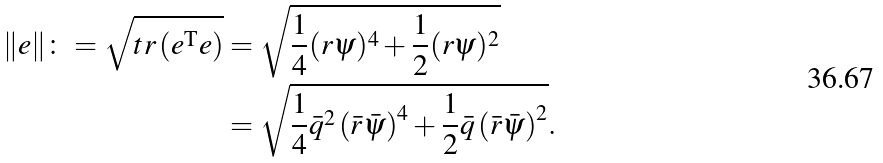<formula> <loc_0><loc_0><loc_500><loc_500>\| e \| \colon = \sqrt { t r \left ( e ^ { \text {T} } e \right ) } & = \sqrt { \frac { 1 } { 4 } ( r \psi ) ^ { 4 } + \frac { 1 } { 2 } ( r \psi ) ^ { 2 } } \\ & = \sqrt { \frac { 1 } { 4 } \bar { q } ^ { 2 } \left ( \bar { r } \bar { \psi } \right ) ^ { 4 } + \frac { 1 } { 2 } \bar { q } \left ( \bar { r } \bar { \psi } \right ) ^ { 2 } } .</formula> 